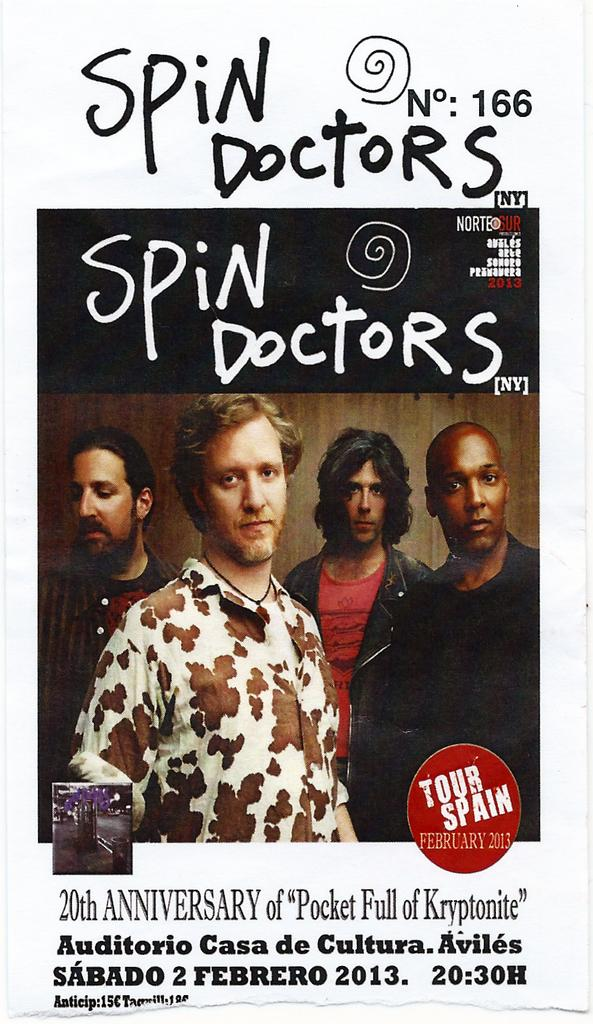<image>
Relay a brief, clear account of the picture shown. The Spin Doctors 20th anniversary tour poster for Spain 